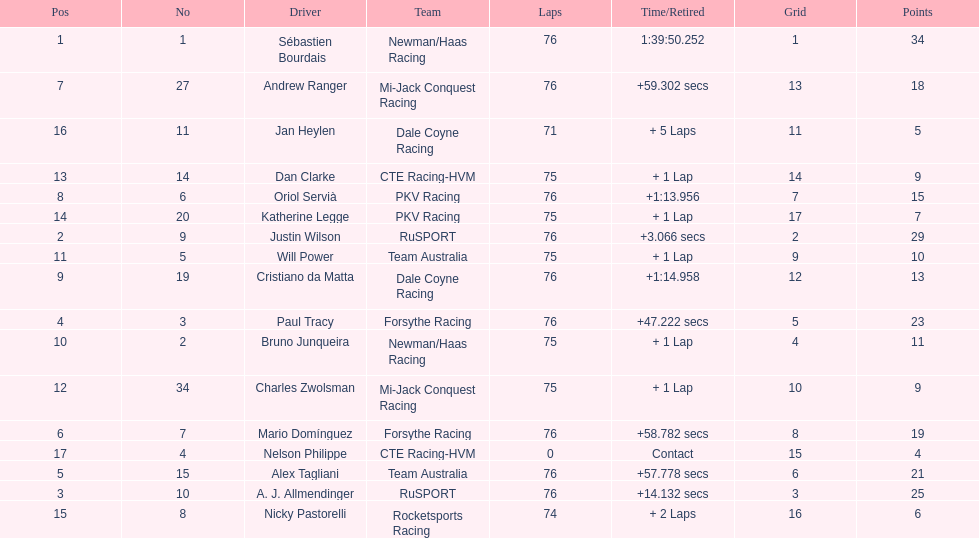How many drivers were competing for brazil? 2. 